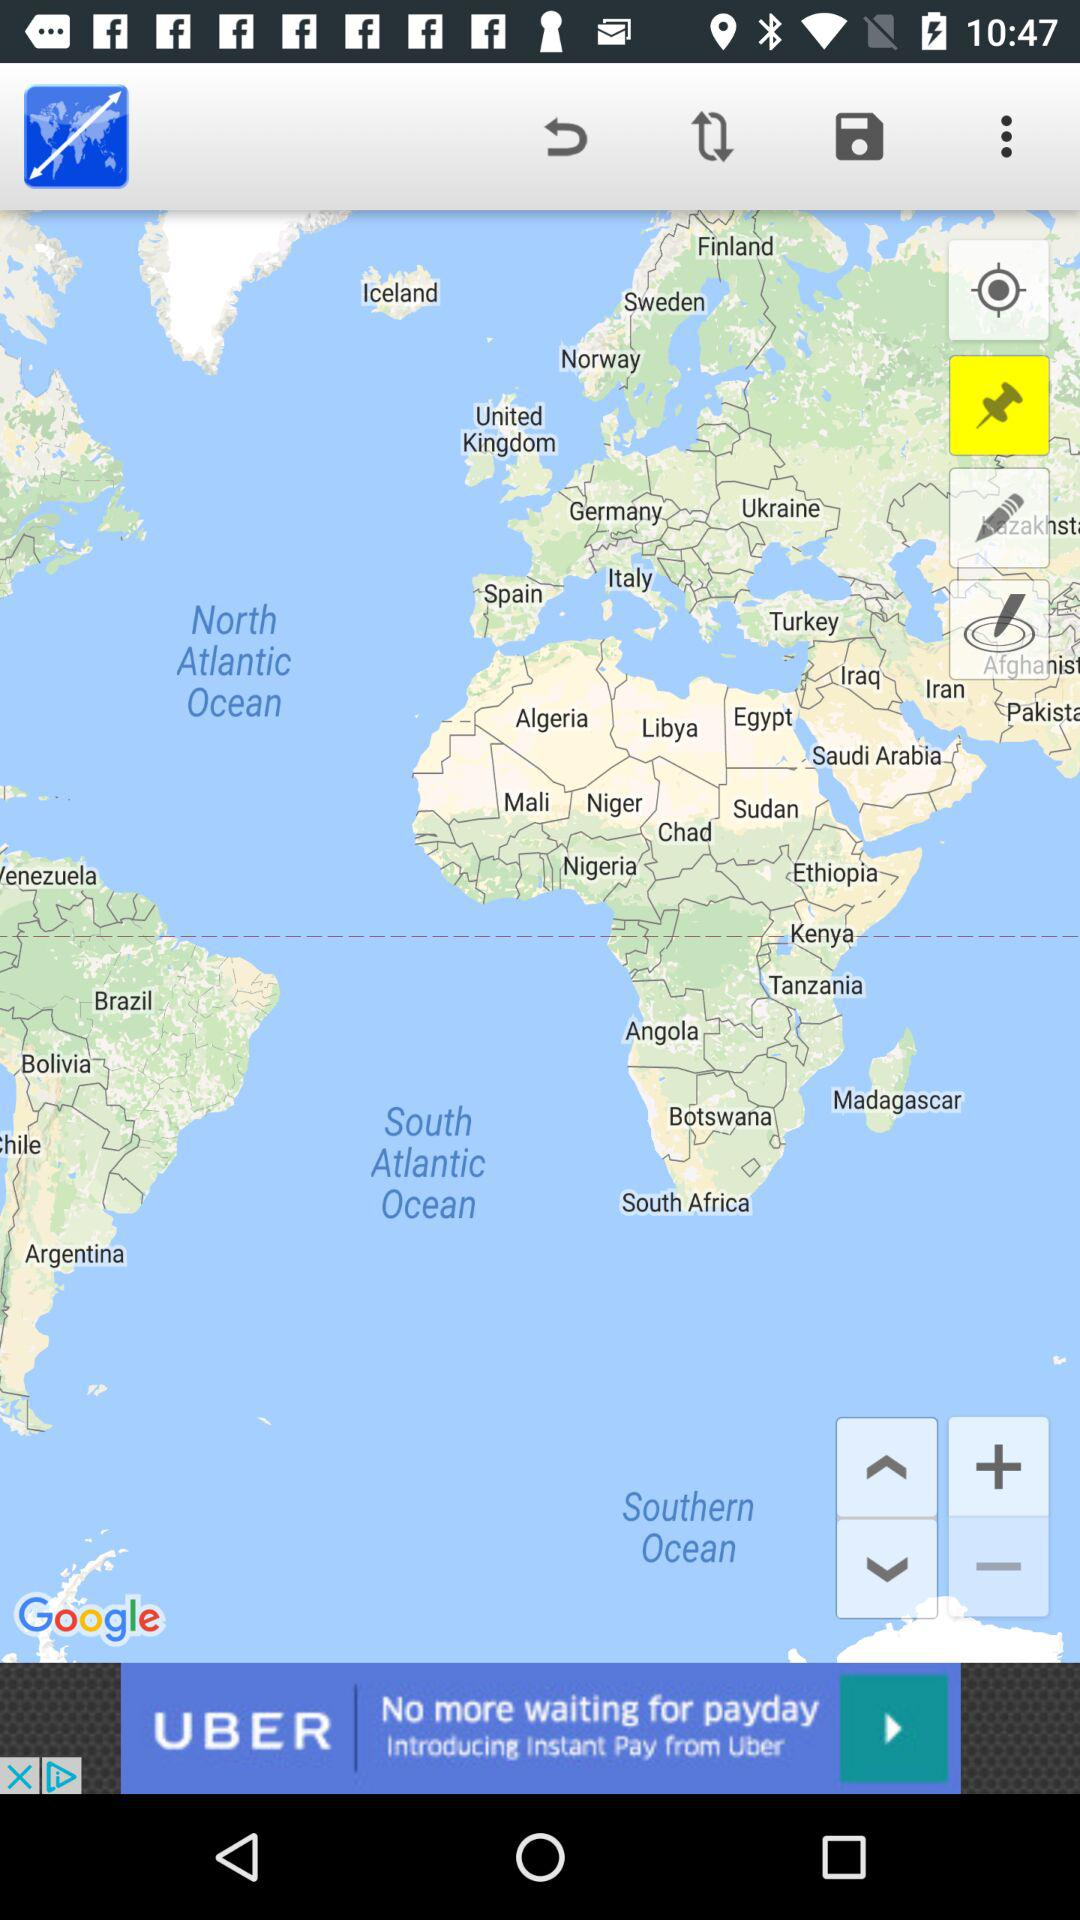What is the selected option? The selected option is "Pin". 